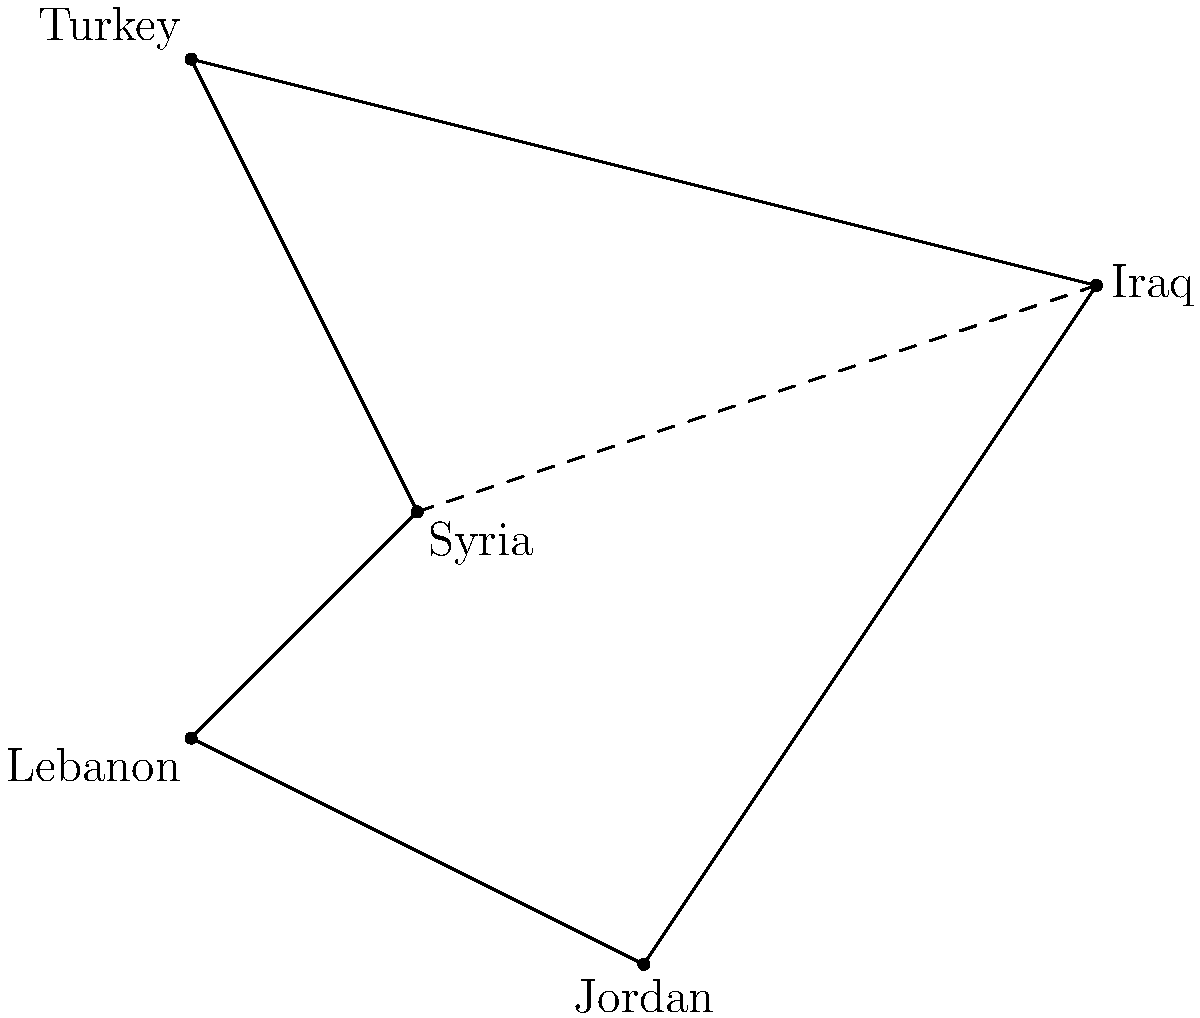On this simplified map of the Middle East, estimate the distance between Syria and Iraq relative to the distance between Syria and Lebanon. How many times farther is Iraq from Syria compared to Lebanon? To solve this problem, we need to follow these steps:

1. Observe the relative positions of Syria, Lebanon, and Iraq on the map.
2. Estimate the distance between Syria and Lebanon visually.
3. Estimate the distance between Syria and Iraq visually.
4. Compare the two distances.

Looking at the map:
1. Syria is at the center, Lebanon is to the southwest, and Iraq is to the east.
2. The distance between Syria and Lebanon appears to be about 1.4 units (using the grid as a reference).
3. The distance between Syria and Iraq appears to be about 3 units.
4. To compare, we divide the longer distance by the shorter:

   $\frac{\text{Syria-Iraq distance}}{\text{Syria-Lebanon distance}} \approx \frac{3}{1.4} \approx 2.14$

This ratio is closest to 2, meaning Iraq is approximately twice as far from Syria as Lebanon is.
Answer: 2 times 